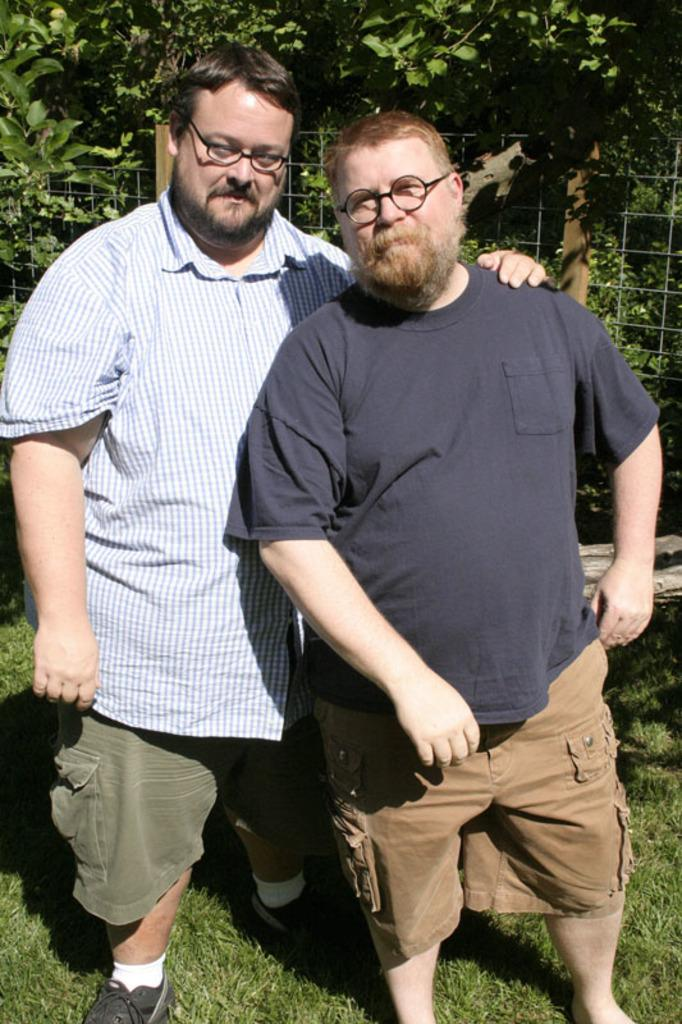What can be seen in the image regarding the people present? There are men standing in the image. What are the men wearing that is noticeable? Both men are wearing spectacles. What type of ground surface is visible in the image? There is grass on the ground in the image. What can be seen in the distance in the image? There are trees visible in the background of the image. What type of barrier is present in the image? There is a metal fence in the image. What town is being measured by the men in the image? There is no indication in the image that the men are measuring a town or any specific location. 